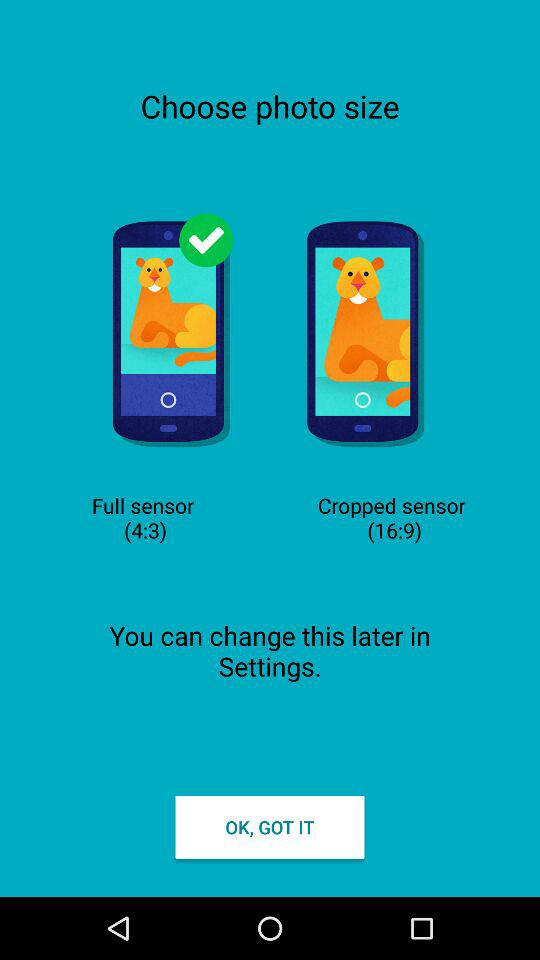What's the full sensor size? The full sensor size is 4:3. 